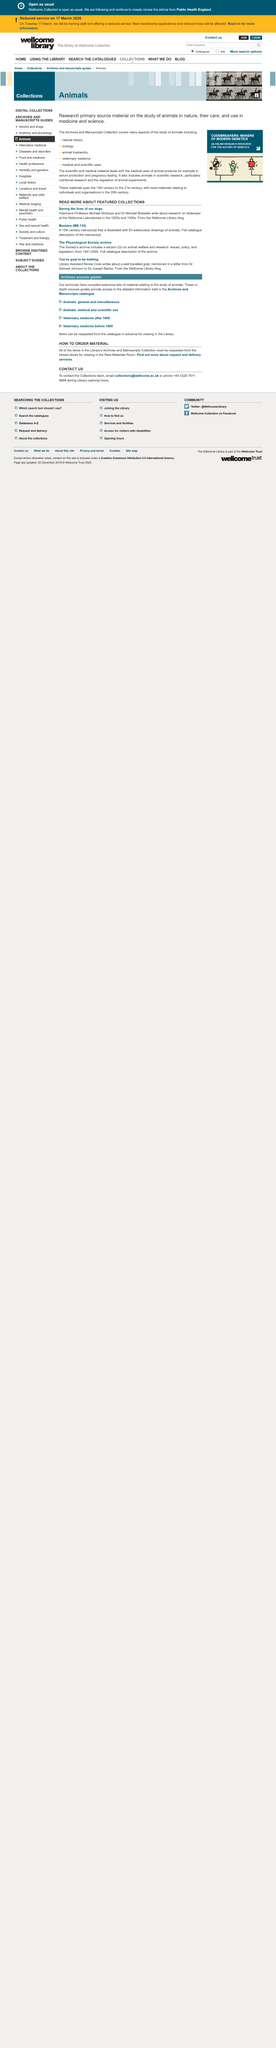Draw attention to some important aspects in this diagram. The 15th century is the earliest date for the featured collection. The first name shared by the researchers at the Wellcome Laboratories is Michael. The manuscript with watercolor drawings of animals is titled 'Bestiary.' 